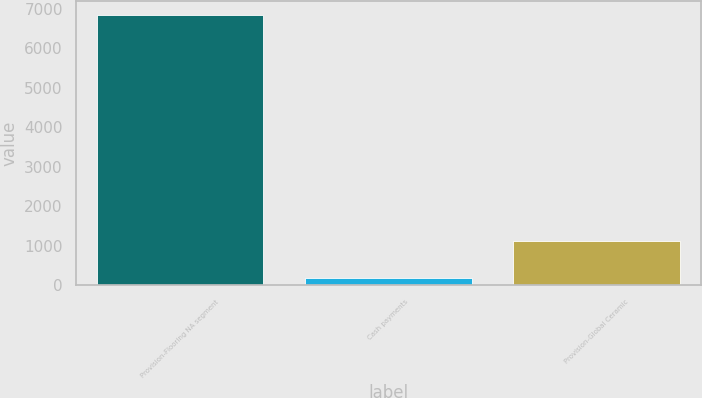Convert chart. <chart><loc_0><loc_0><loc_500><loc_500><bar_chart><fcel>Provision-Flooring NA segment<fcel>Cash payments<fcel>Provision-Global Ceramic<nl><fcel>6849<fcel>190<fcel>1131<nl></chart> 